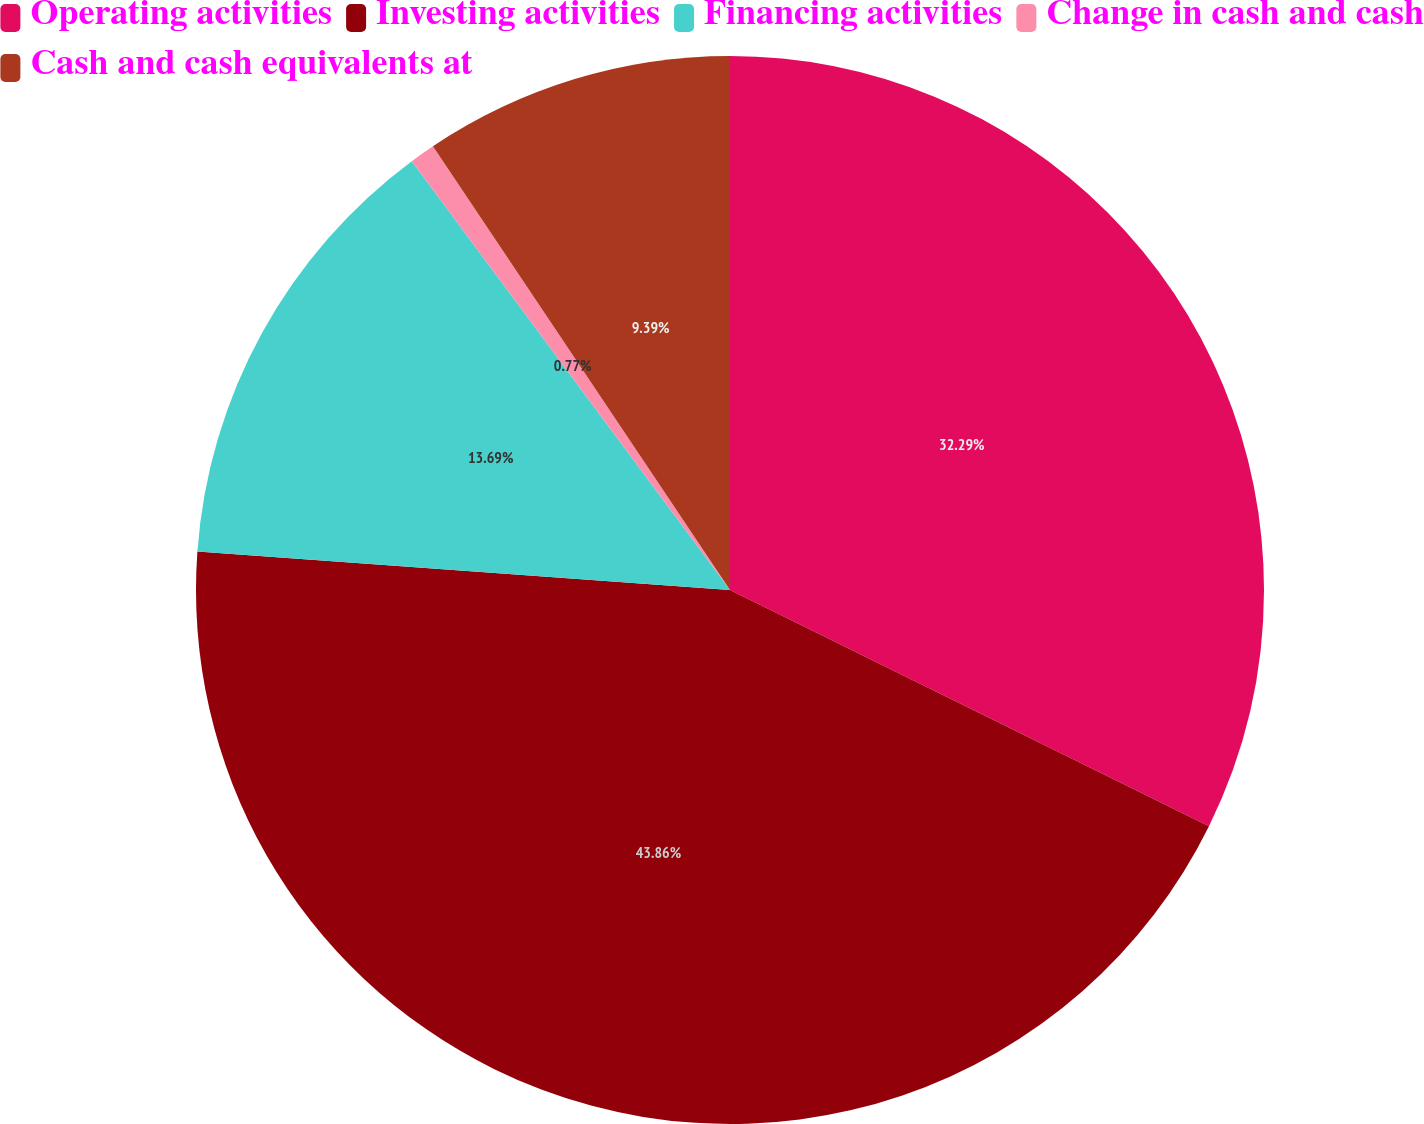Convert chart to OTSL. <chart><loc_0><loc_0><loc_500><loc_500><pie_chart><fcel>Operating activities<fcel>Investing activities<fcel>Financing activities<fcel>Change in cash and cash<fcel>Cash and cash equivalents at<nl><fcel>32.29%<fcel>43.86%<fcel>13.69%<fcel>0.77%<fcel>9.39%<nl></chart> 